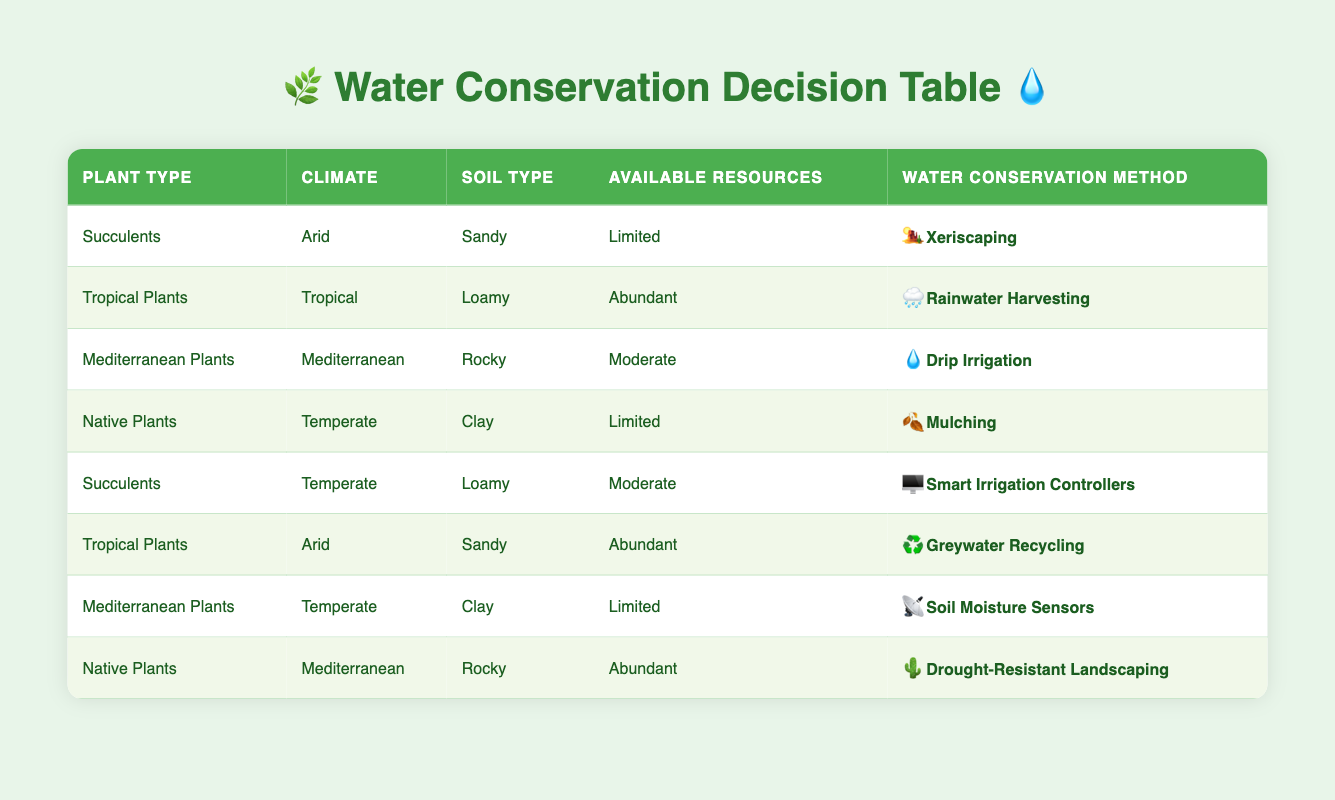What is the water conservation method for Tropical Plants in a Tropical climate with Loamy soil and Abundant resources? The table directly shows that for Tropical Plants in a Tropical climate with Loamy soil and Abundant resources, the recommended water conservation method is Rainwater Harvesting.
Answer: Rainwater Harvesting Which water conservation method is suggested for Native Plants in Temperate climate with Limited resources? According to the table, Native Plants in a Temperate climate with Limited resources should use Mulching.
Answer: Mulching How many different water conservation methods are listed in total? The table shows a total of 8 different water conservation methods listed under the Water Conservation Method column.
Answer: 8 Is Drip Irrigation suitable for Mediterranean Plants in any climate? Looking at the table, Drip Irrigation is only recommended for Mediterranean Plants in a Mediterranean climate with Rocky soil and Moderate resources. Therefore, the answer is no, it is not suitable for other climates.
Answer: No Which plant type has the recommended water conservation method of Soil Moisture Sensors? By checking the table, we see that Mediterranean Plants in a Temperate climate with Clay soil and Limited resources are recommended to use Soil Moisture Sensors.
Answer: Mediterranean Plants What is the relationship between soil type and the recommended water conservation methods for Succulents in Temperate and Arid climates? For Succulents in a Temperate climate with Loamy soil and Moderate resources, the recommended method is Smart Irrigation Controllers. In contrast, for Succulents in an Arid climate with Sandy soil and Limited resources, Xeriscaping is suggested. This indicates that soil type and the corresponding climate impact the choice of water conservation method significantly.
Answer: Different methods based on soil type How many plant types are suggested to use Xeriscaping as a water conservation method? From the table, it shows that only one plant type, Succulents in Arid conditions with Sandy soil and Limited resources, is suggested to use Xeriscaping.
Answer: 1 If a gardener has Moderate resources and wants to cultivate Tropical Plants, what is the best water conservation method according to the table? The table indicates that if a gardener has Moderate resources for Tropical Plants, there isn't a specific recommended method mentioned for this combination, as all related methods are designated for either Abundant or Limited resources in specific climates. Therefore, the answer should reflect that more information might be needed.
Answer: Not specified Which water conservation methods are recommended for plants in Arid climates? The table specifies two methods for Arid climates: Xeriscaping for Succulents with Limited resources, and Greywater Recycling for Tropical Plants with Abundant resources. This indicates these methods are tailored to the resource availability specifically for Arid conditions.
Answer: Xeriscaping and Greywater Recycling 